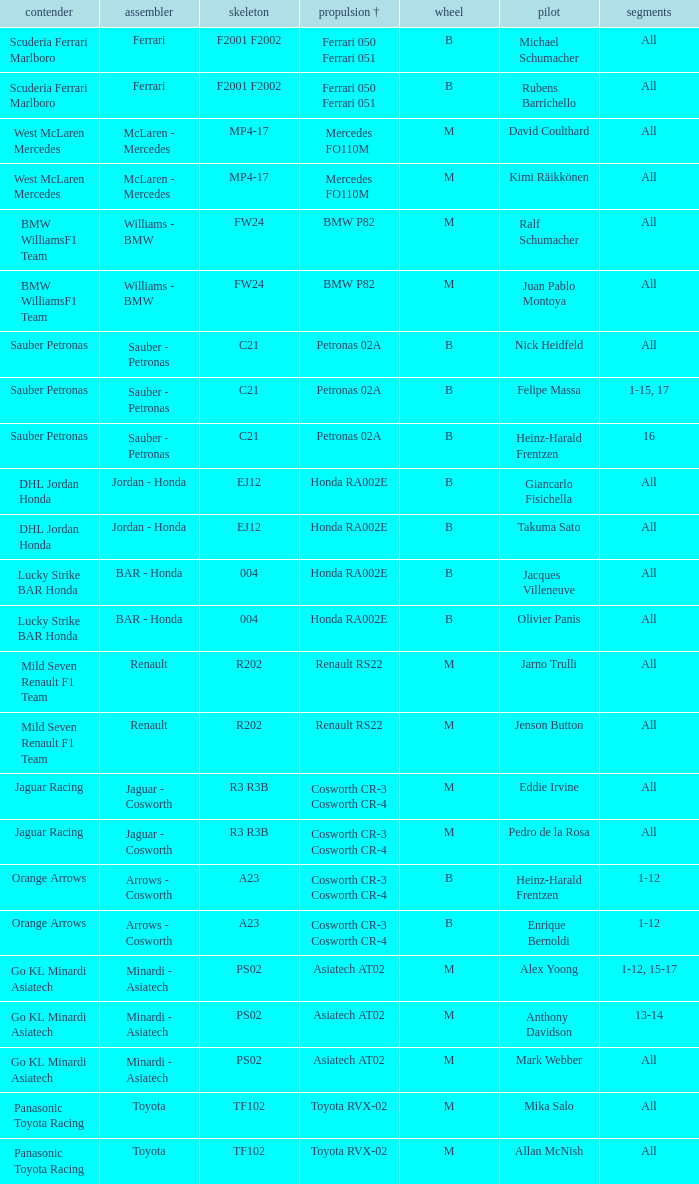Who is the driver when the engine is mercedes fo110m? David Coulthard, Kimi Räikkönen. 